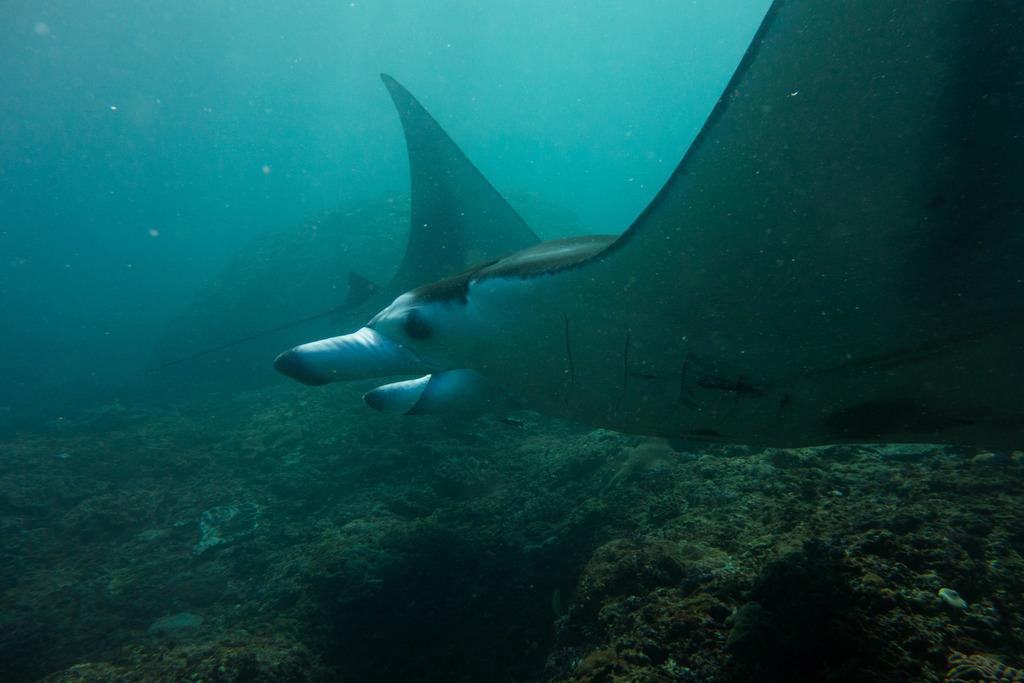What type of environment is depicted in the image? The image shows an underwater environment. What can be seen in the underwater environment? There are underwater objects and aquatic animals in the image. What type of ducks can be seen swimming in the image? There are no ducks present in the image, as it depicts an underwater environment with aquatic animals. How does the underwater environment affect the hearing of the aquatic animals in the image? The provided facts do not mention anything about the hearing of the aquatic animals, so we cannot answer this question based on the information given. 